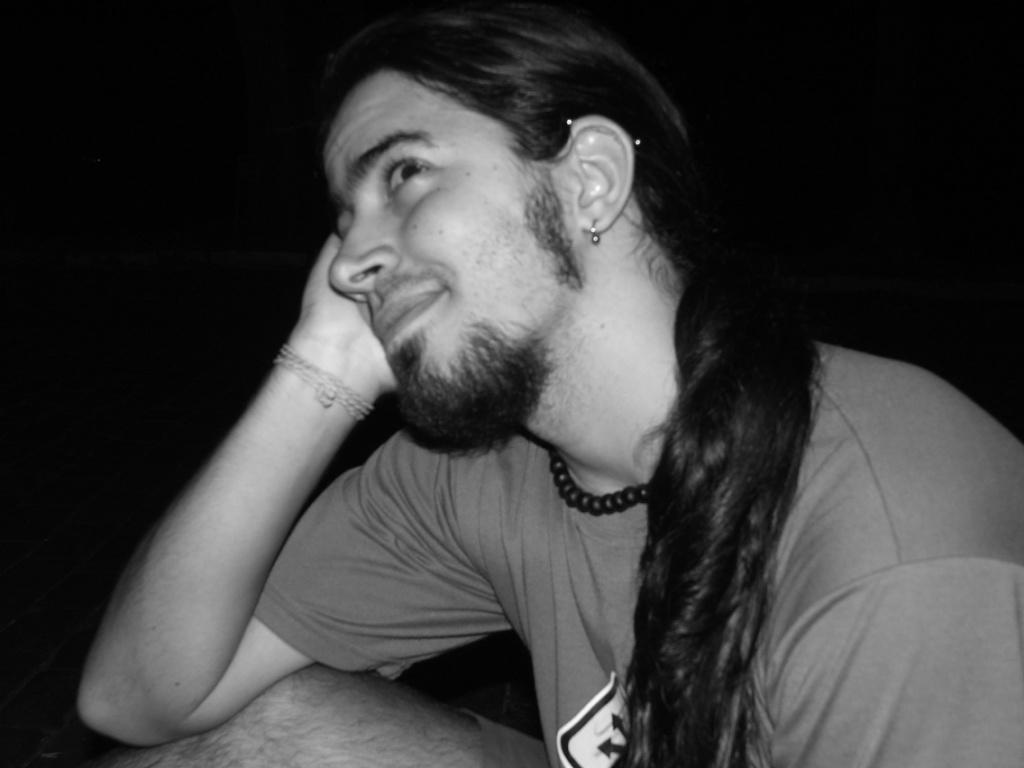How would you summarize this image in a sentence or two? In this image there is a man sitting, he is wearing a T-shirt, the background of the image is dark. 